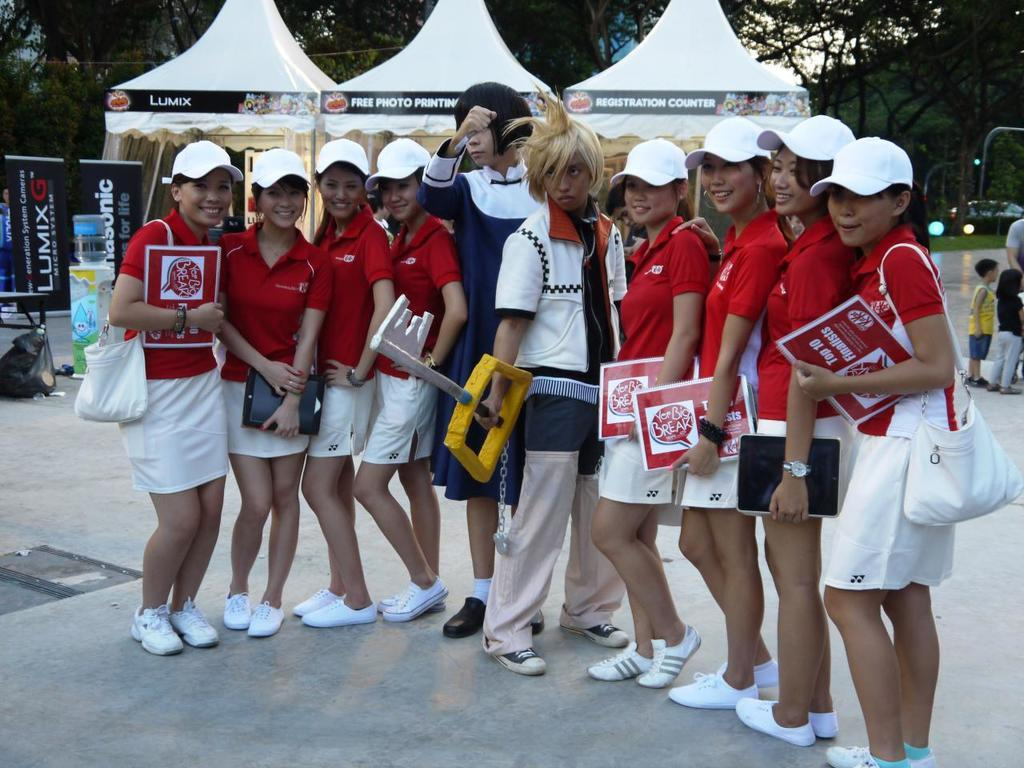Provide a one-sentence caption for the provided image. A group of women in matching outfits stands around two anime characters as they hold paper identifying them as top ten finalists. 